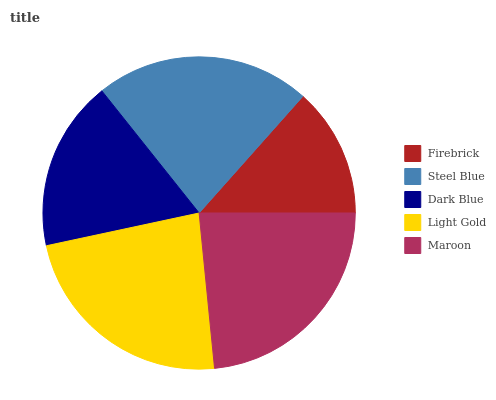Is Firebrick the minimum?
Answer yes or no. Yes. Is Maroon the maximum?
Answer yes or no. Yes. Is Steel Blue the minimum?
Answer yes or no. No. Is Steel Blue the maximum?
Answer yes or no. No. Is Steel Blue greater than Firebrick?
Answer yes or no. Yes. Is Firebrick less than Steel Blue?
Answer yes or no. Yes. Is Firebrick greater than Steel Blue?
Answer yes or no. No. Is Steel Blue less than Firebrick?
Answer yes or no. No. Is Steel Blue the high median?
Answer yes or no. Yes. Is Steel Blue the low median?
Answer yes or no. Yes. Is Firebrick the high median?
Answer yes or no. No. Is Light Gold the low median?
Answer yes or no. No. 